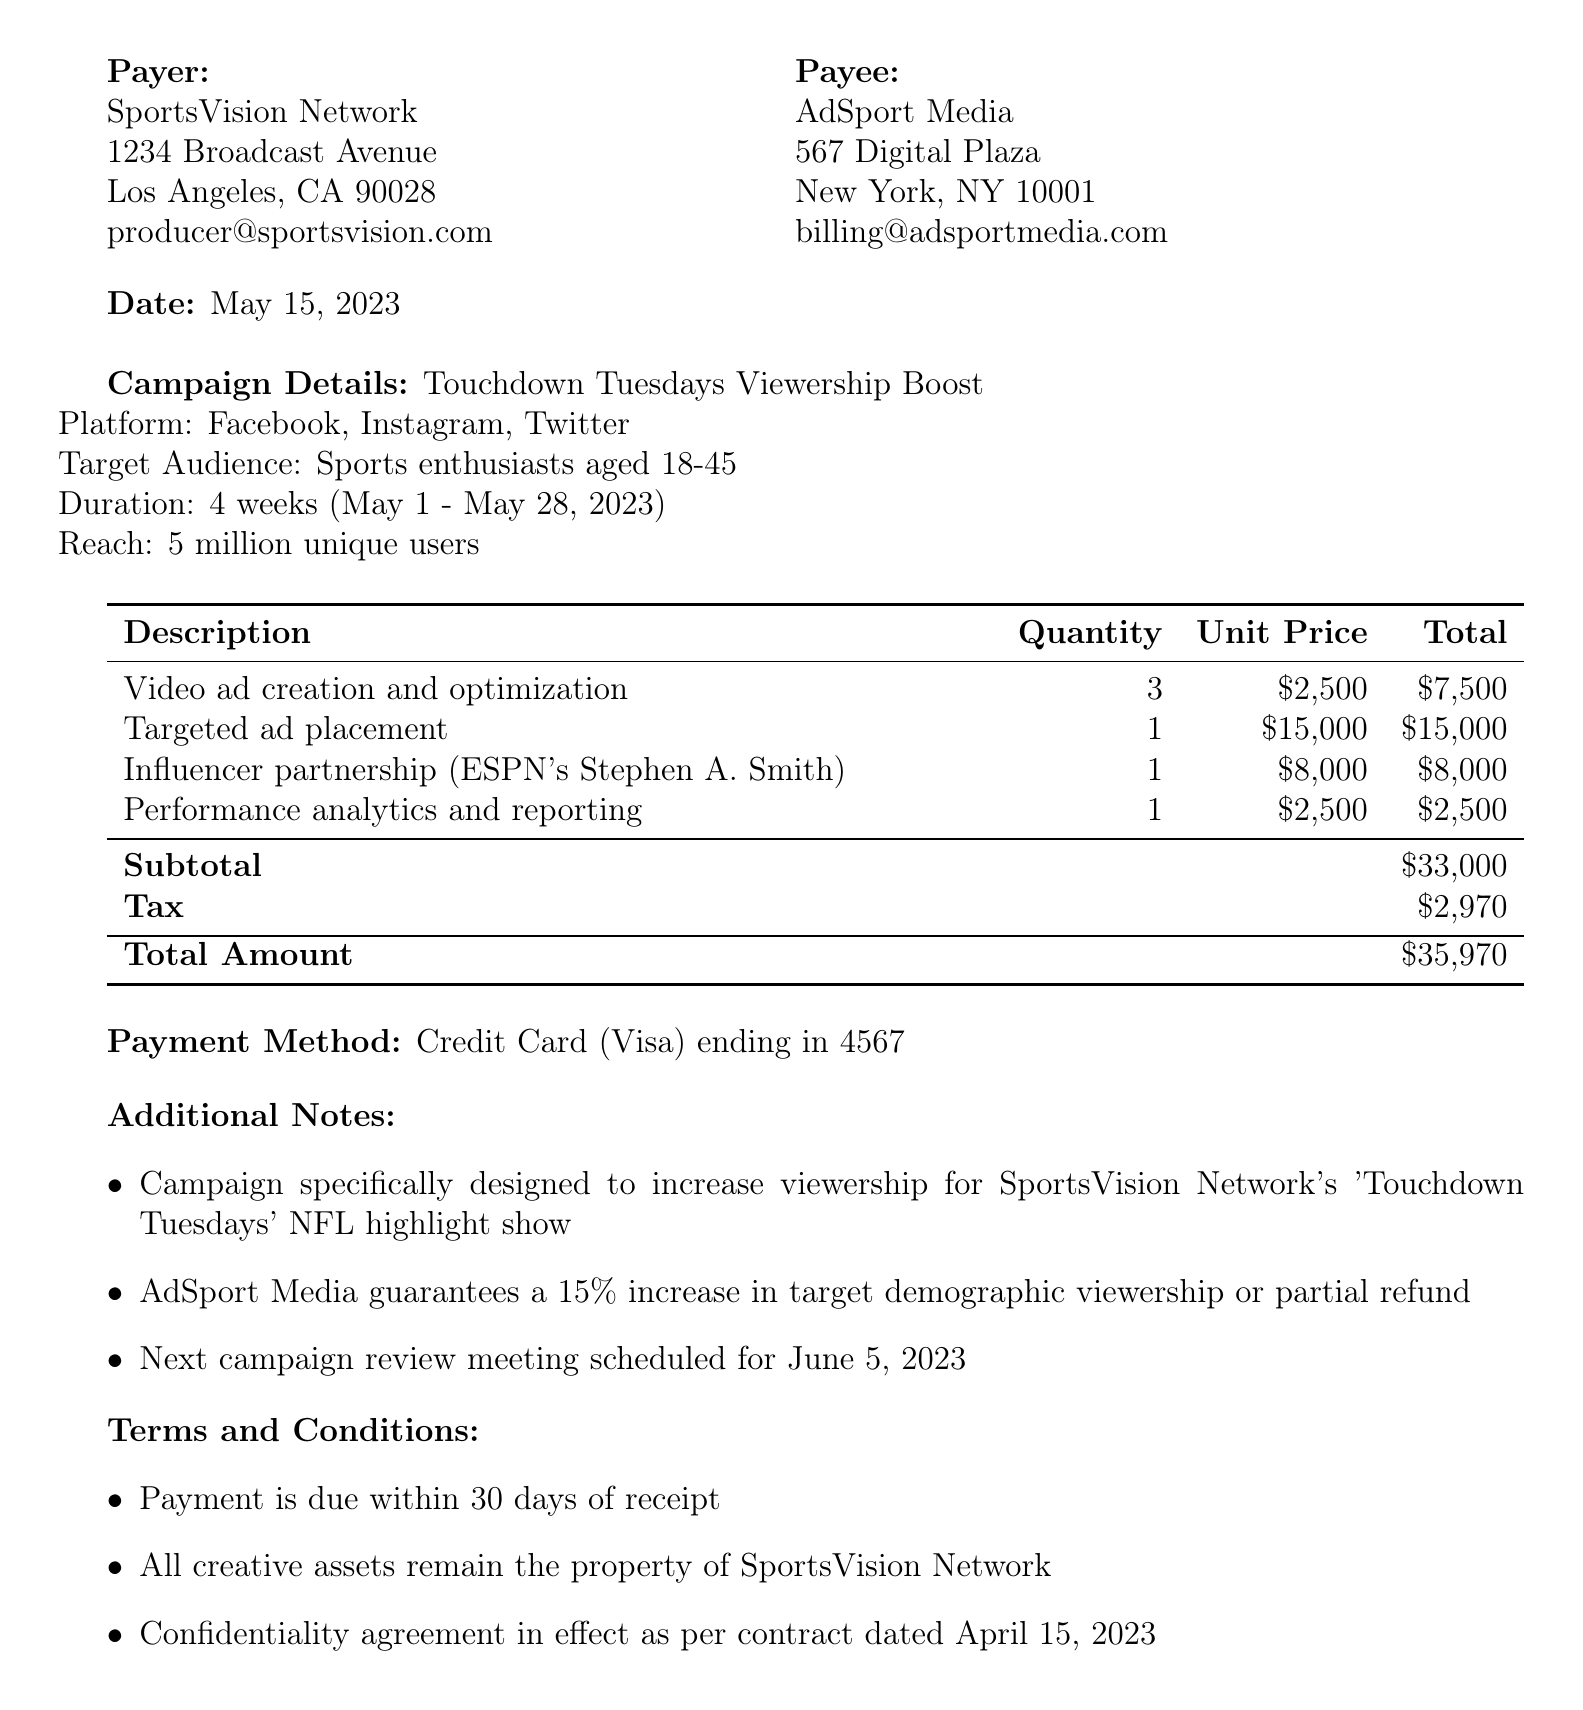What is the transaction ID? The transaction ID is specifically mentioned in the document, which is SMC-2023-0542.
Answer: SMC-2023-0542 What is the total amount paid? The total amount is calculated at the end of the document and is stated as $35,970.
Answer: $35,970 Who is the payer? The payer's name is clearly indicated in the document as SportsVision Network.
Answer: SportsVision Network What is the duration of the campaign? The duration of the campaign is listed in the campaign details section as 4 weeks (May 1 - May 28, 2023).
Answer: 4 weeks (May 1 - May 28, 2023) What platform is used for the advertisement? The document specifies the advertising platforms in the campaign details, which are Facebook, Instagram, and Twitter.
Answer: Facebook, Instagram, Twitter What services are included in the payment? The document lists several services provided, including video ad creation, targeted ad placement, influencer partnership, and performance analytics.
Answer: Video ad creation, targeted ad placement, influencer partnership, performance analytics What is the tax amount? The tax amount is stated in the totals section of the document, which is $2,970.
Answer: $2,970 What is the payment method used? The payment method is mentioned in the document and is Credit Card (Visa) ending in 4567.
Answer: Credit Card (Visa) ending in 4567 What is the campaign's target audience? The target audience is specified in the campaign details and is sports enthusiasts aged 18-45.
Answer: Sports enthusiasts aged 18-45 